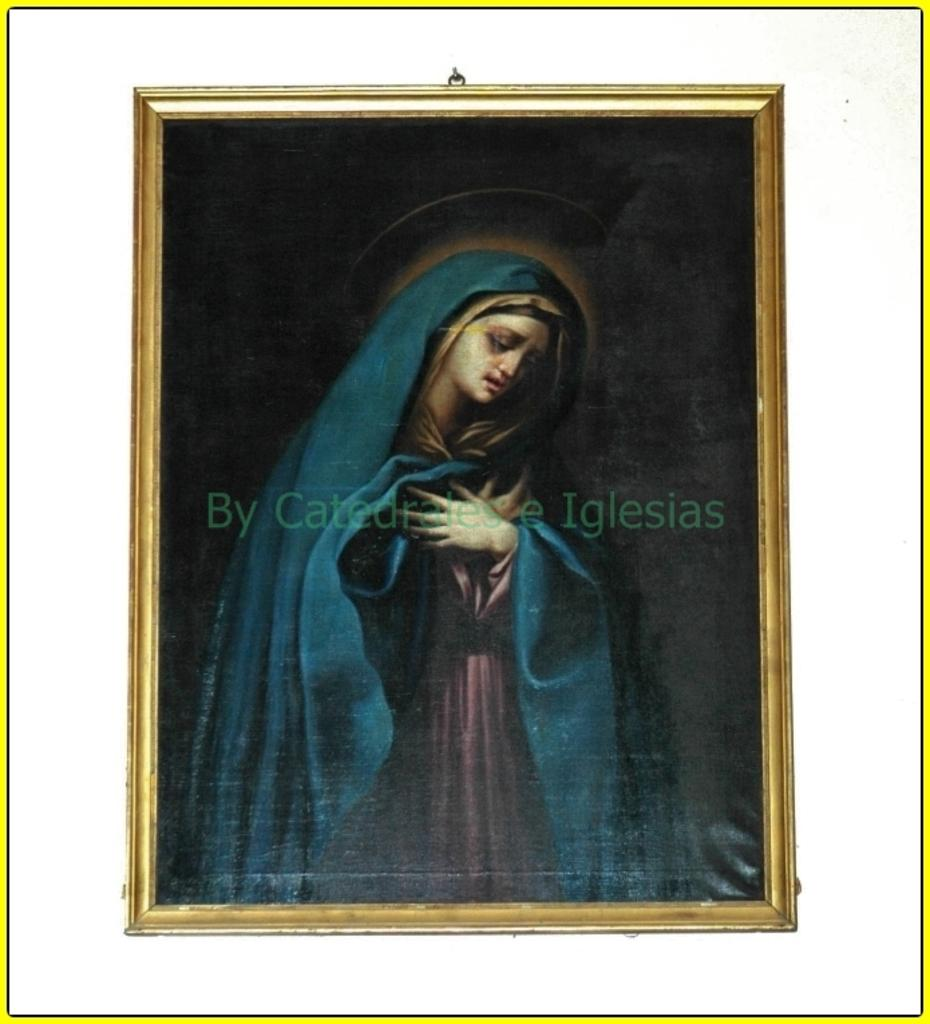What is the main subject in the center of the image? There is a frame in the center of the image. What can be seen inside the frame? A person is present in the frame. Are there any words or letters in the center of the image? Yes, there is text in the center of the image. What type of sheet is covering the marble in the image? There is no sheet or marble present in the image. How many faucets can be seen in the image? There are no faucets present in the image. 